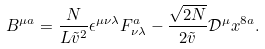<formula> <loc_0><loc_0><loc_500><loc_500>B ^ { \mu a } = \frac { N } { L \tilde { v } ^ { 2 } } \epsilon ^ { \mu \nu \lambda } F _ { \nu \lambda } ^ { a } - \frac { \sqrt { 2 N } } { 2 \tilde { v } } \mathcal { D } ^ { \mu } x ^ { 8 a } .</formula> 